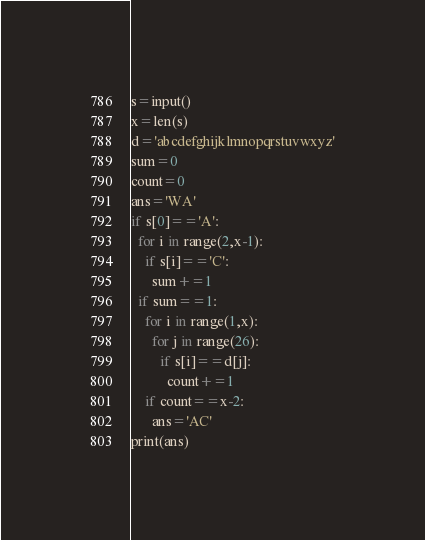Convert code to text. <code><loc_0><loc_0><loc_500><loc_500><_Python_>s=input()
x=len(s)
d='abcdefghijklmnopqrstuvwxyz'
sum=0
count=0
ans='WA'
if s[0]=='A':
  for i in range(2,x-1):
    if s[i]=='C':
      sum+=1
  if sum==1:
    for i in range(1,x):
      for j in range(26):
        if s[i]==d[j]:
          count+=1
    if count==x-2:
      ans='AC'
print(ans)  </code> 